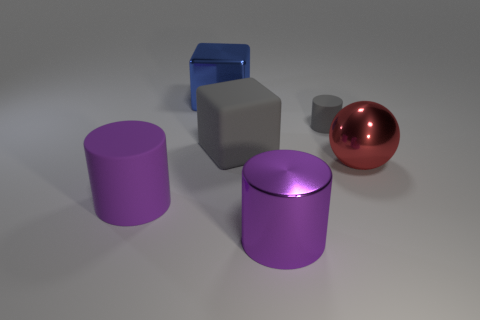Add 4 balls. How many objects exist? 10 Subtract all cubes. How many objects are left? 4 Add 1 large cubes. How many large cubes are left? 3 Add 4 big brown metal spheres. How many big brown metal spheres exist? 4 Subtract 0 blue spheres. How many objects are left? 6 Subtract all blue blocks. Subtract all metal cubes. How many objects are left? 4 